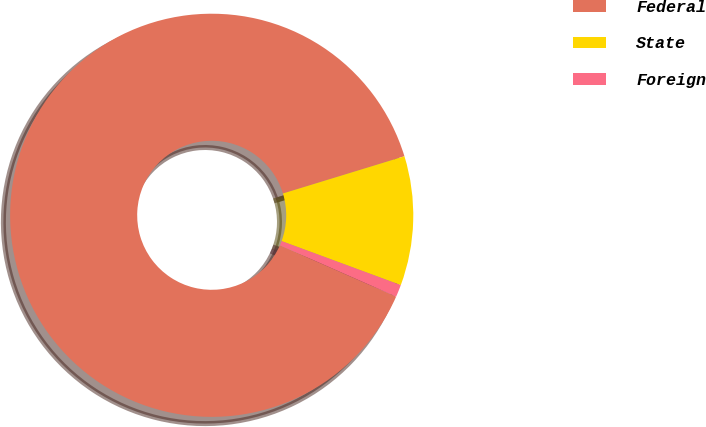Convert chart. <chart><loc_0><loc_0><loc_500><loc_500><pie_chart><fcel>Federal<fcel>State<fcel>Foreign<nl><fcel>88.65%<fcel>10.36%<fcel>0.98%<nl></chart> 